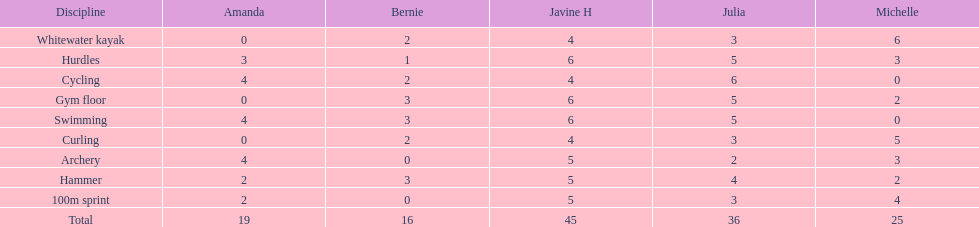What is the mean score for a 100m dash? 2.8. 